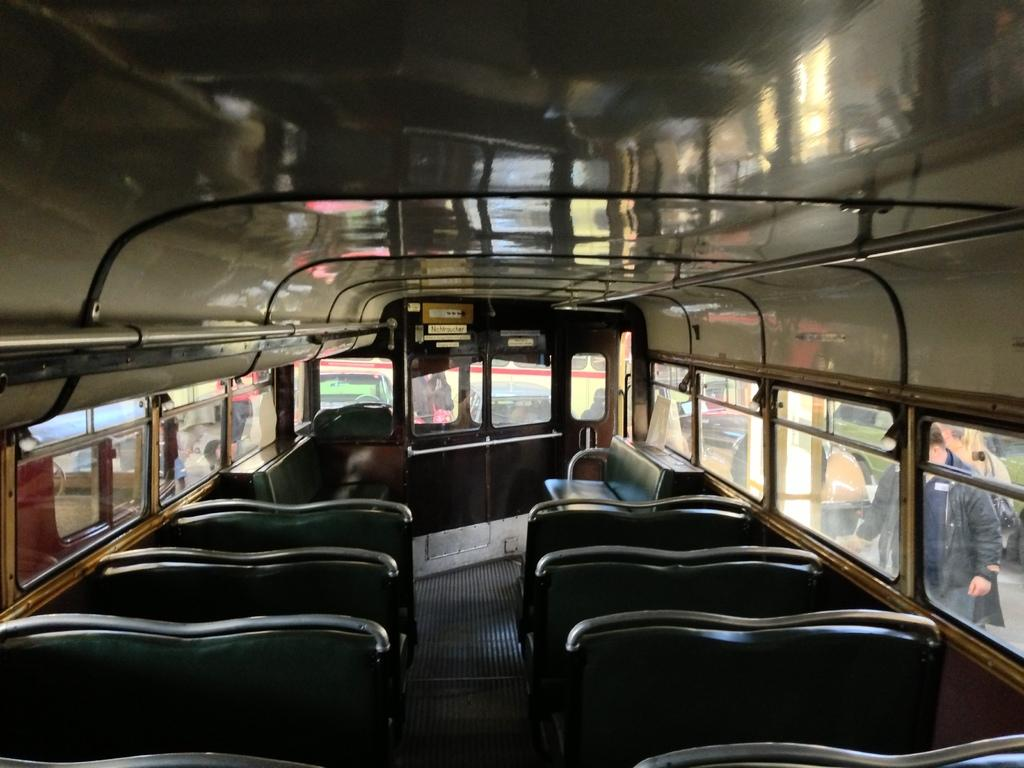What type of vehicle is shown in the image? The image is an inside view of a bus. What can be found inside the bus? There are seats in the bus. How can passengers enter or exit the bus? There is a door in the bus. What can be seen outside the bus through the windows? People and grass are visible through the windows. What is the opinion of the fuel efficiency of the bus in the image? The image does not provide any information about the fuel efficiency of the bus, so it cannot be determined from the image. 